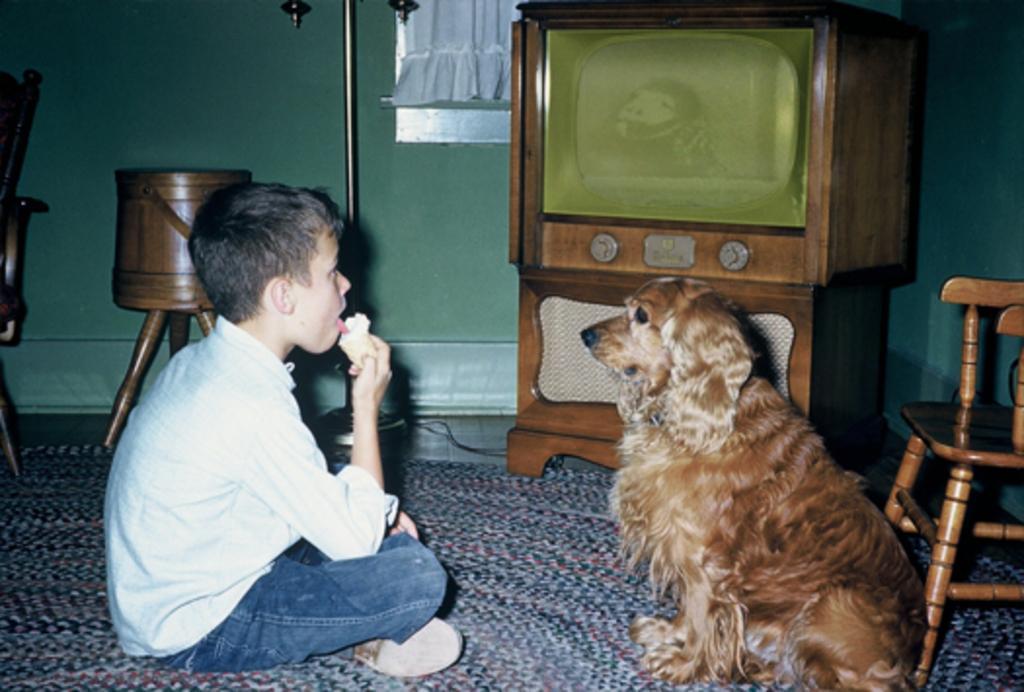In one or two sentences, can you explain what this image depicts? This is the picture in side of the room. He is sitting in a room. There was a dog in front of him. He eats ice cream. We can see in the background there is a curtain ,drums and stand next to it. 